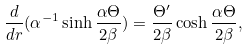<formula> <loc_0><loc_0><loc_500><loc_500>\frac { d } { d r } ( \alpha ^ { - 1 } \sinh \frac { \alpha \Theta } { 2 \beta } ) = \frac { \Theta ^ { \prime } } { 2 \beta } \cosh \frac { \alpha \Theta } { 2 \beta } ,</formula> 